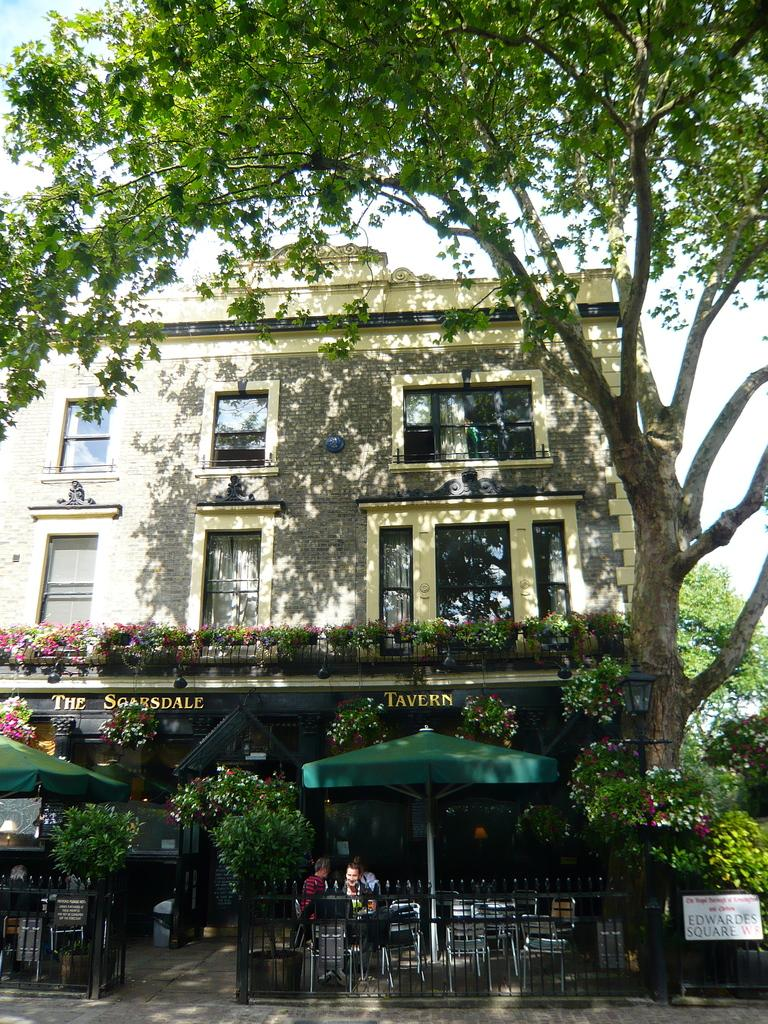What type of structure is visible in the image? There is a building in the image. What other natural elements can be seen in the image? There are trees in the image. What type of furniture is present in the image? There are chairs and tables in the image. What objects are used for shade in the image? There are umbrellas in the image. What are the people in the image doing? The people are seated on the chairs. How would you describe the weather in the image? The sky is cloudy in the image. Is there any quicksand visible in the image? No, there is no quicksand present in the image. What type of club can be seen in the image? There is no club visible in the image. 